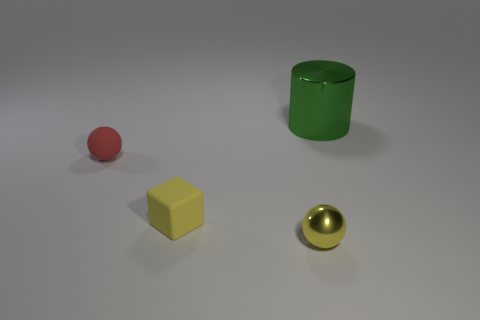Subtract all blocks. How many objects are left? 3 Subtract all small brown cylinders. Subtract all tiny yellow cubes. How many objects are left? 3 Add 2 red balls. How many red balls are left? 3 Add 4 big red metallic things. How many big red metallic things exist? 4 Add 1 red matte balls. How many objects exist? 5 Subtract all yellow balls. How many balls are left? 1 Subtract 0 blue spheres. How many objects are left? 4 Subtract all blue blocks. Subtract all green cylinders. How many blocks are left? 1 Subtract all blue cubes. How many red cylinders are left? 0 